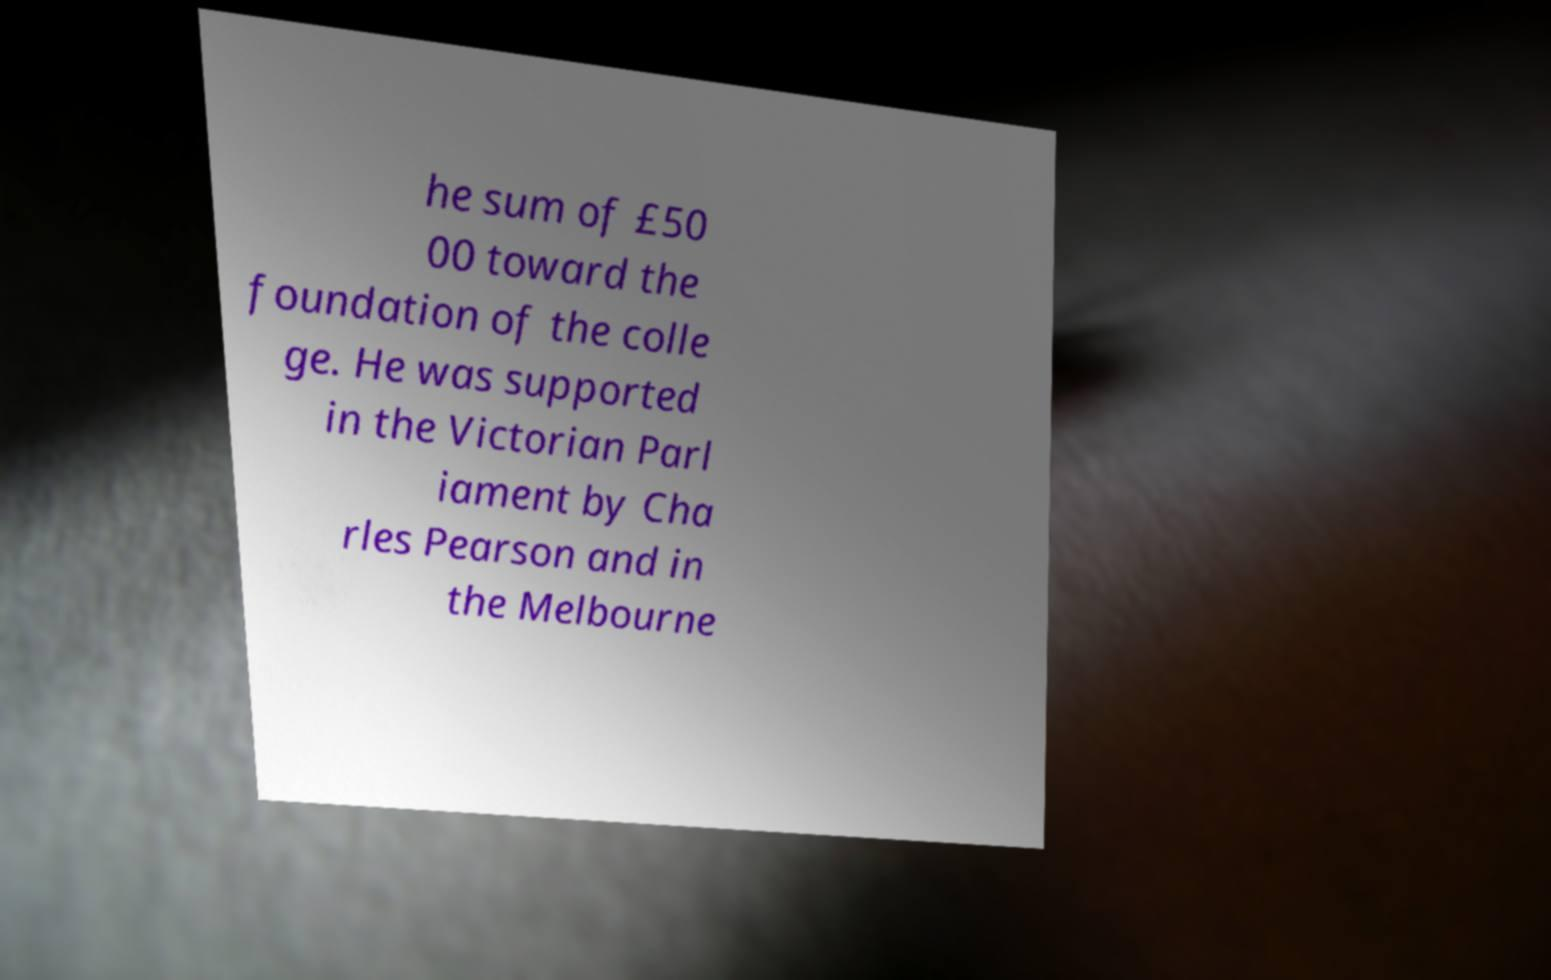What messages or text are displayed in this image? I need them in a readable, typed format. he sum of £50 00 toward the foundation of the colle ge. He was supported in the Victorian Parl iament by Cha rles Pearson and in the Melbourne 